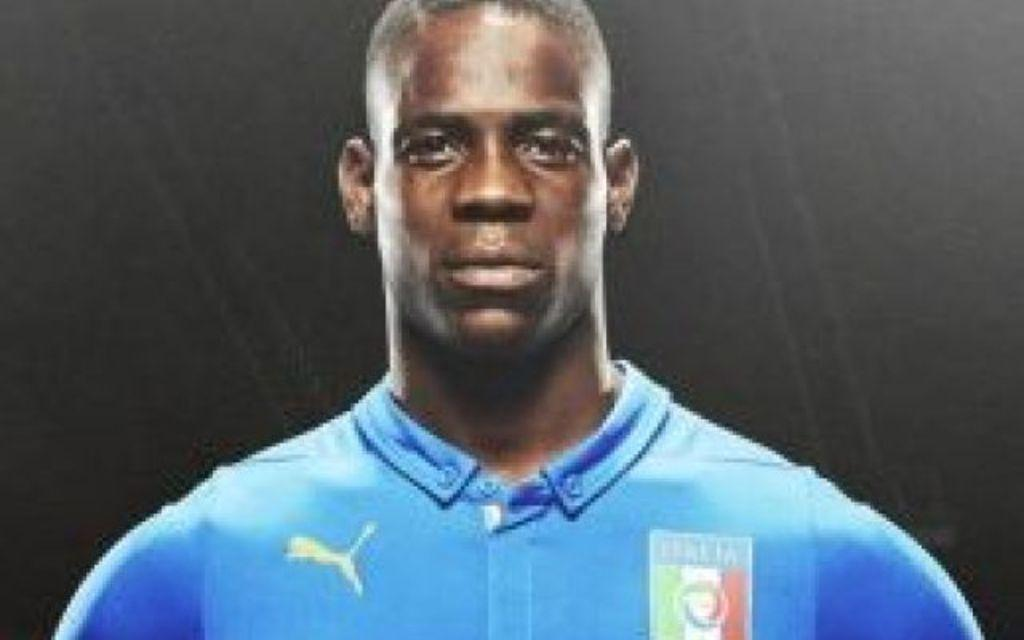What is present in the image that stands out? There is a banner in the image. What is depicted on the banner? There is a man on the banner. What is the man wearing? The man is wearing a blue dress. What type of disease is the man on the banner suffering from? There is no indication in the image that the man is suffering from any disease. 